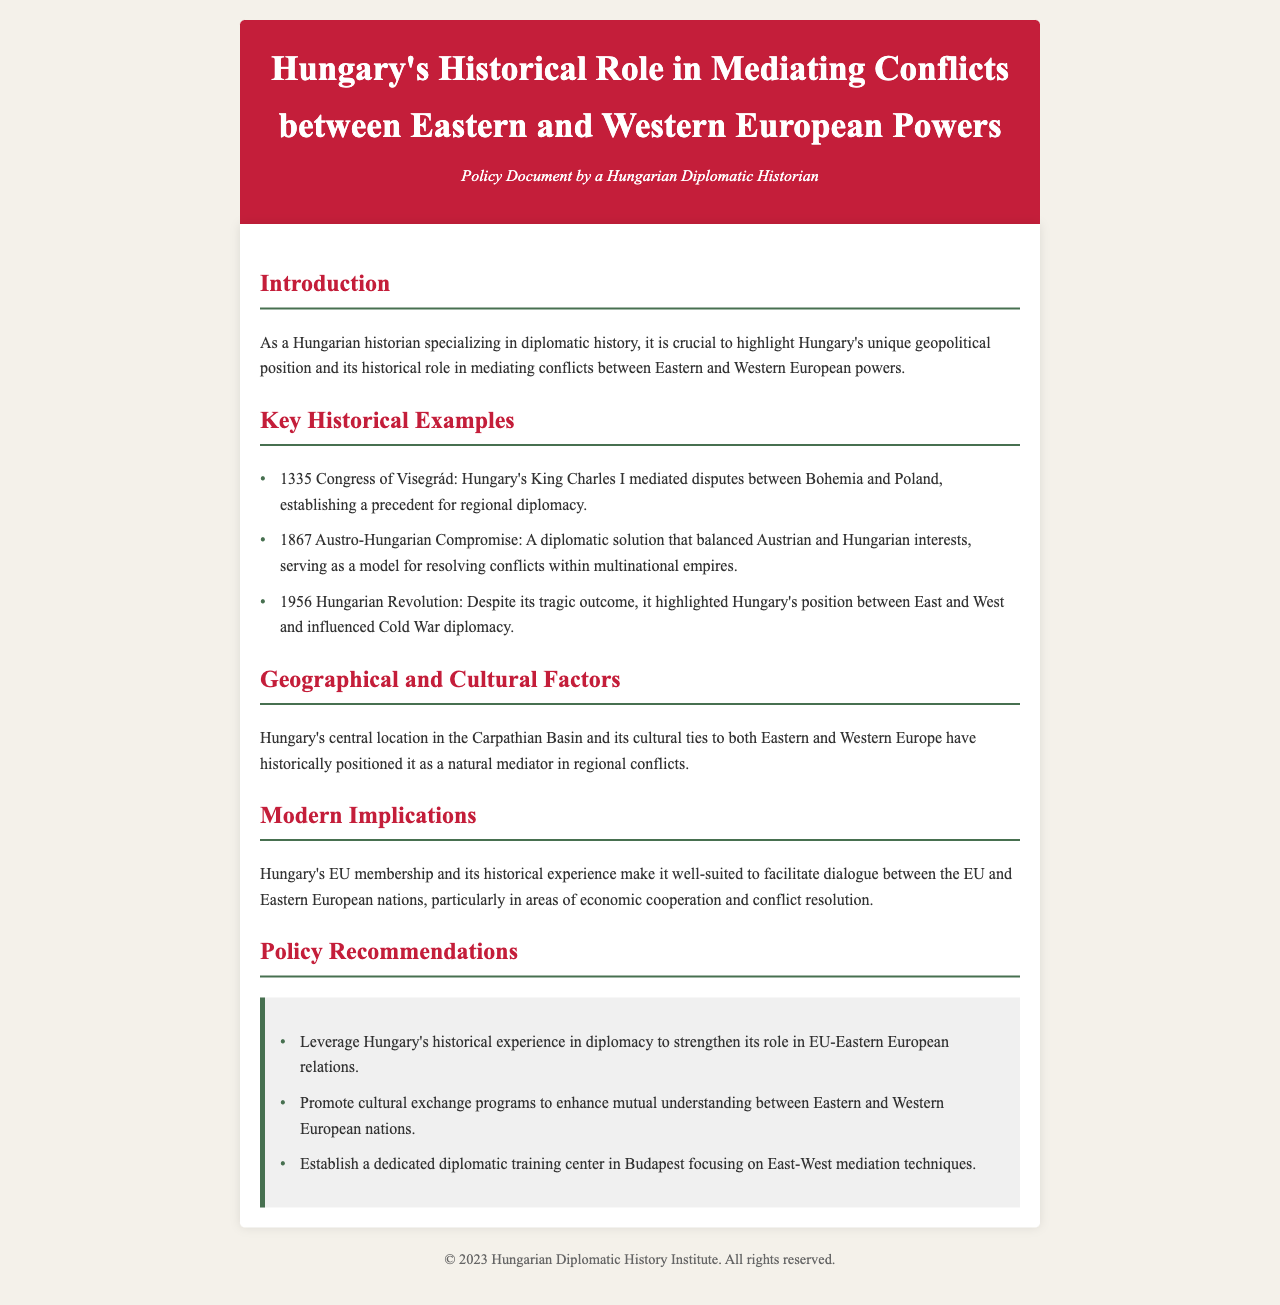what year was the Congress of Visegrád held? The Congress of Visegrád took place in 1335, as mentioned in the document's key historical examples.
Answer: 1335 who mediated disputes between Bohemia and Poland? The document states that Hungary's King Charles I mediated the disputes, indicating his role in the Congress of Visegrád.
Answer: King Charles I what does the document suggest Hungary can leverage to strengthen its role in EU relations? The document suggests leveraging Hungary's historical experience in diplomacy to enhance its involvement in EU-Eastern European relations.
Answer: historical experience what was the outcome of the 1956 Hungarian Revolution? According to the document, despite its tragic outcome, it highlighted Hungary's position between East and West.
Answer: tragic outcome what type of center does the document recommend establishing in Budapest? The policy recommendations section suggests establishing a dedicated diplomatic training center in Budapest focusing on East-West mediation techniques.
Answer: diplomatic training center how many key historical examples are listed in the document? By counting the items in the Key Historical Examples section, we find that there are three examples listed.
Answer: three what is the primary geographical feature that positions Hungary as a mediator? The geographical and cultural factors section notes Hungary's central location in the Carpathian Basin as pivotal for its mediating role.
Answer: central location which year marks the Austro-Hungarian Compromise mentioned in the document? The document notes the Austro-Hungarian Compromise occurred in 1867.
Answer: 1867 what kind of programs does the document recommend to enhance understanding between nations? The document recommends promoting cultural exchange programs to foster mutual understanding among Eastern and Western European nations.
Answer: cultural exchange programs 